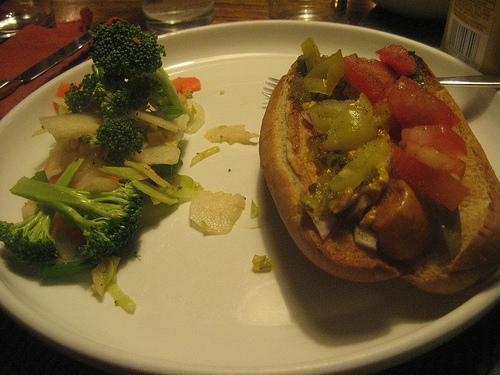How many plates are in the picture?
Give a very brief answer. 1. 